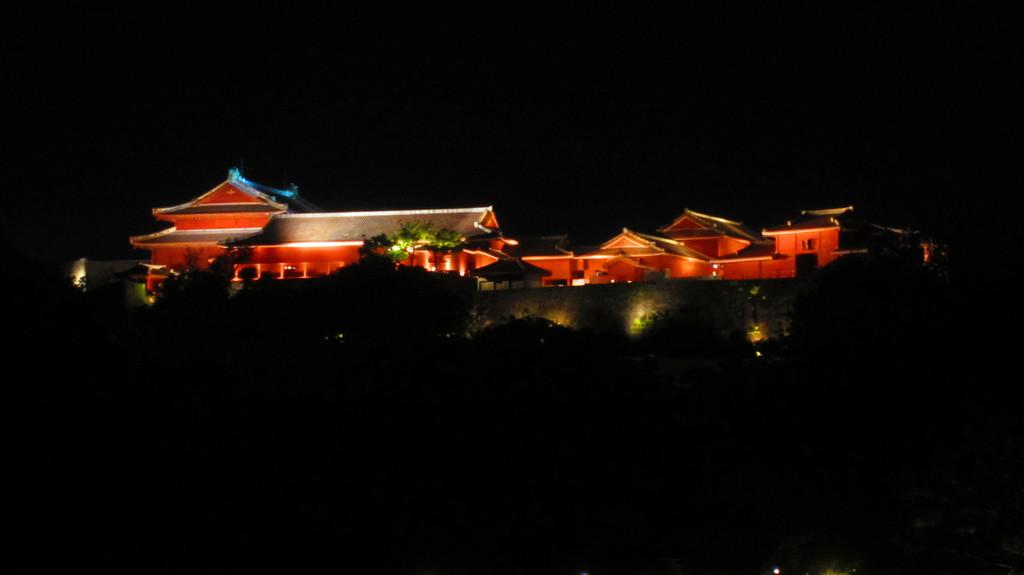What can be seen in the foreground of the image? There are buildings, lights, and trees in the foreground of the image. What is the overall appearance of the image? The image has a dark appearance. What type of unit is being used to measure the height of the trees in the image? There is no unit present in the image, and the height of the trees is not being measured. Can you see a bed in the image? No, there is no bed present in the image. 